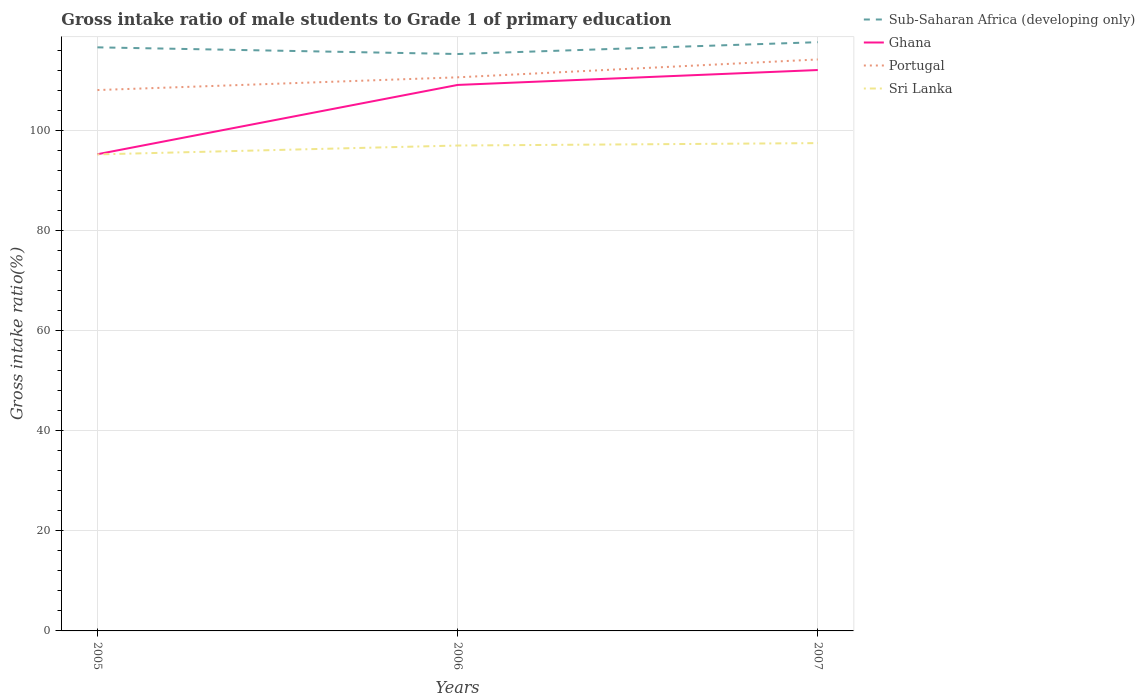How many different coloured lines are there?
Ensure brevity in your answer.  4. Does the line corresponding to Portugal intersect with the line corresponding to Ghana?
Ensure brevity in your answer.  No. Across all years, what is the maximum gross intake ratio in Sri Lanka?
Keep it short and to the point. 95.27. What is the total gross intake ratio in Sub-Saharan Africa (developing only) in the graph?
Offer a very short reply. 1.33. What is the difference between the highest and the second highest gross intake ratio in Sri Lanka?
Your answer should be very brief. 2.26. How many years are there in the graph?
Give a very brief answer. 3. Where does the legend appear in the graph?
Give a very brief answer. Top right. How many legend labels are there?
Provide a short and direct response. 4. How are the legend labels stacked?
Offer a very short reply. Vertical. What is the title of the graph?
Provide a short and direct response. Gross intake ratio of male students to Grade 1 of primary education. Does "Turkmenistan" appear as one of the legend labels in the graph?
Offer a very short reply. No. What is the label or title of the X-axis?
Offer a very short reply. Years. What is the label or title of the Y-axis?
Make the answer very short. Gross intake ratio(%). What is the Gross intake ratio(%) of Sub-Saharan Africa (developing only) in 2005?
Provide a short and direct response. 116.67. What is the Gross intake ratio(%) of Ghana in 2005?
Offer a terse response. 95.3. What is the Gross intake ratio(%) of Portugal in 2005?
Your answer should be compact. 108.13. What is the Gross intake ratio(%) in Sri Lanka in 2005?
Your answer should be compact. 95.27. What is the Gross intake ratio(%) in Sub-Saharan Africa (developing only) in 2006?
Make the answer very short. 115.34. What is the Gross intake ratio(%) in Ghana in 2006?
Ensure brevity in your answer.  109.15. What is the Gross intake ratio(%) of Portugal in 2006?
Keep it short and to the point. 110.68. What is the Gross intake ratio(%) in Sri Lanka in 2006?
Make the answer very short. 97.04. What is the Gross intake ratio(%) in Sub-Saharan Africa (developing only) in 2007?
Your answer should be very brief. 117.7. What is the Gross intake ratio(%) in Ghana in 2007?
Your answer should be compact. 112.13. What is the Gross intake ratio(%) of Portugal in 2007?
Your answer should be very brief. 114.25. What is the Gross intake ratio(%) of Sri Lanka in 2007?
Your answer should be very brief. 97.52. Across all years, what is the maximum Gross intake ratio(%) in Sub-Saharan Africa (developing only)?
Make the answer very short. 117.7. Across all years, what is the maximum Gross intake ratio(%) in Ghana?
Give a very brief answer. 112.13. Across all years, what is the maximum Gross intake ratio(%) of Portugal?
Give a very brief answer. 114.25. Across all years, what is the maximum Gross intake ratio(%) in Sri Lanka?
Your answer should be very brief. 97.52. Across all years, what is the minimum Gross intake ratio(%) in Sub-Saharan Africa (developing only)?
Your answer should be very brief. 115.34. Across all years, what is the minimum Gross intake ratio(%) of Ghana?
Provide a succinct answer. 95.3. Across all years, what is the minimum Gross intake ratio(%) of Portugal?
Keep it short and to the point. 108.13. Across all years, what is the minimum Gross intake ratio(%) of Sri Lanka?
Your response must be concise. 95.27. What is the total Gross intake ratio(%) of Sub-Saharan Africa (developing only) in the graph?
Make the answer very short. 349.71. What is the total Gross intake ratio(%) in Ghana in the graph?
Your answer should be very brief. 316.59. What is the total Gross intake ratio(%) in Portugal in the graph?
Make the answer very short. 333.06. What is the total Gross intake ratio(%) of Sri Lanka in the graph?
Give a very brief answer. 289.83. What is the difference between the Gross intake ratio(%) of Sub-Saharan Africa (developing only) in 2005 and that in 2006?
Offer a terse response. 1.33. What is the difference between the Gross intake ratio(%) in Ghana in 2005 and that in 2006?
Your response must be concise. -13.85. What is the difference between the Gross intake ratio(%) of Portugal in 2005 and that in 2006?
Make the answer very short. -2.55. What is the difference between the Gross intake ratio(%) of Sri Lanka in 2005 and that in 2006?
Keep it short and to the point. -1.78. What is the difference between the Gross intake ratio(%) of Sub-Saharan Africa (developing only) in 2005 and that in 2007?
Make the answer very short. -1.03. What is the difference between the Gross intake ratio(%) of Ghana in 2005 and that in 2007?
Keep it short and to the point. -16.83. What is the difference between the Gross intake ratio(%) of Portugal in 2005 and that in 2007?
Provide a short and direct response. -6.12. What is the difference between the Gross intake ratio(%) in Sri Lanka in 2005 and that in 2007?
Make the answer very short. -2.26. What is the difference between the Gross intake ratio(%) of Sub-Saharan Africa (developing only) in 2006 and that in 2007?
Make the answer very short. -2.36. What is the difference between the Gross intake ratio(%) of Ghana in 2006 and that in 2007?
Offer a terse response. -2.98. What is the difference between the Gross intake ratio(%) of Portugal in 2006 and that in 2007?
Your response must be concise. -3.57. What is the difference between the Gross intake ratio(%) in Sri Lanka in 2006 and that in 2007?
Your answer should be very brief. -0.48. What is the difference between the Gross intake ratio(%) in Sub-Saharan Africa (developing only) in 2005 and the Gross intake ratio(%) in Ghana in 2006?
Ensure brevity in your answer.  7.52. What is the difference between the Gross intake ratio(%) of Sub-Saharan Africa (developing only) in 2005 and the Gross intake ratio(%) of Portugal in 2006?
Your response must be concise. 5.99. What is the difference between the Gross intake ratio(%) in Sub-Saharan Africa (developing only) in 2005 and the Gross intake ratio(%) in Sri Lanka in 2006?
Provide a succinct answer. 19.63. What is the difference between the Gross intake ratio(%) in Ghana in 2005 and the Gross intake ratio(%) in Portugal in 2006?
Your response must be concise. -15.38. What is the difference between the Gross intake ratio(%) of Ghana in 2005 and the Gross intake ratio(%) of Sri Lanka in 2006?
Your answer should be very brief. -1.74. What is the difference between the Gross intake ratio(%) of Portugal in 2005 and the Gross intake ratio(%) of Sri Lanka in 2006?
Provide a short and direct response. 11.09. What is the difference between the Gross intake ratio(%) of Sub-Saharan Africa (developing only) in 2005 and the Gross intake ratio(%) of Ghana in 2007?
Give a very brief answer. 4.54. What is the difference between the Gross intake ratio(%) in Sub-Saharan Africa (developing only) in 2005 and the Gross intake ratio(%) in Portugal in 2007?
Keep it short and to the point. 2.42. What is the difference between the Gross intake ratio(%) in Sub-Saharan Africa (developing only) in 2005 and the Gross intake ratio(%) in Sri Lanka in 2007?
Offer a terse response. 19.15. What is the difference between the Gross intake ratio(%) of Ghana in 2005 and the Gross intake ratio(%) of Portugal in 2007?
Offer a very short reply. -18.95. What is the difference between the Gross intake ratio(%) in Ghana in 2005 and the Gross intake ratio(%) in Sri Lanka in 2007?
Offer a terse response. -2.22. What is the difference between the Gross intake ratio(%) in Portugal in 2005 and the Gross intake ratio(%) in Sri Lanka in 2007?
Provide a short and direct response. 10.61. What is the difference between the Gross intake ratio(%) of Sub-Saharan Africa (developing only) in 2006 and the Gross intake ratio(%) of Ghana in 2007?
Offer a very short reply. 3.2. What is the difference between the Gross intake ratio(%) in Sub-Saharan Africa (developing only) in 2006 and the Gross intake ratio(%) in Portugal in 2007?
Offer a very short reply. 1.09. What is the difference between the Gross intake ratio(%) in Sub-Saharan Africa (developing only) in 2006 and the Gross intake ratio(%) in Sri Lanka in 2007?
Your response must be concise. 17.81. What is the difference between the Gross intake ratio(%) in Ghana in 2006 and the Gross intake ratio(%) in Portugal in 2007?
Give a very brief answer. -5.09. What is the difference between the Gross intake ratio(%) in Ghana in 2006 and the Gross intake ratio(%) in Sri Lanka in 2007?
Your response must be concise. 11.63. What is the difference between the Gross intake ratio(%) in Portugal in 2006 and the Gross intake ratio(%) in Sri Lanka in 2007?
Make the answer very short. 13.15. What is the average Gross intake ratio(%) in Sub-Saharan Africa (developing only) per year?
Provide a succinct answer. 116.57. What is the average Gross intake ratio(%) in Ghana per year?
Provide a short and direct response. 105.53. What is the average Gross intake ratio(%) in Portugal per year?
Your answer should be compact. 111.02. What is the average Gross intake ratio(%) of Sri Lanka per year?
Offer a terse response. 96.61. In the year 2005, what is the difference between the Gross intake ratio(%) of Sub-Saharan Africa (developing only) and Gross intake ratio(%) of Ghana?
Provide a short and direct response. 21.37. In the year 2005, what is the difference between the Gross intake ratio(%) in Sub-Saharan Africa (developing only) and Gross intake ratio(%) in Portugal?
Make the answer very short. 8.54. In the year 2005, what is the difference between the Gross intake ratio(%) in Sub-Saharan Africa (developing only) and Gross intake ratio(%) in Sri Lanka?
Offer a terse response. 21.4. In the year 2005, what is the difference between the Gross intake ratio(%) in Ghana and Gross intake ratio(%) in Portugal?
Your answer should be very brief. -12.83. In the year 2005, what is the difference between the Gross intake ratio(%) of Ghana and Gross intake ratio(%) of Sri Lanka?
Offer a very short reply. 0.03. In the year 2005, what is the difference between the Gross intake ratio(%) of Portugal and Gross intake ratio(%) of Sri Lanka?
Make the answer very short. 12.86. In the year 2006, what is the difference between the Gross intake ratio(%) of Sub-Saharan Africa (developing only) and Gross intake ratio(%) of Ghana?
Your response must be concise. 6.18. In the year 2006, what is the difference between the Gross intake ratio(%) in Sub-Saharan Africa (developing only) and Gross intake ratio(%) in Portugal?
Make the answer very short. 4.66. In the year 2006, what is the difference between the Gross intake ratio(%) in Sub-Saharan Africa (developing only) and Gross intake ratio(%) in Sri Lanka?
Offer a very short reply. 18.3. In the year 2006, what is the difference between the Gross intake ratio(%) in Ghana and Gross intake ratio(%) in Portugal?
Offer a terse response. -1.52. In the year 2006, what is the difference between the Gross intake ratio(%) of Ghana and Gross intake ratio(%) of Sri Lanka?
Offer a terse response. 12.11. In the year 2006, what is the difference between the Gross intake ratio(%) of Portugal and Gross intake ratio(%) of Sri Lanka?
Keep it short and to the point. 13.64. In the year 2007, what is the difference between the Gross intake ratio(%) in Sub-Saharan Africa (developing only) and Gross intake ratio(%) in Ghana?
Your answer should be compact. 5.57. In the year 2007, what is the difference between the Gross intake ratio(%) in Sub-Saharan Africa (developing only) and Gross intake ratio(%) in Portugal?
Offer a very short reply. 3.45. In the year 2007, what is the difference between the Gross intake ratio(%) of Sub-Saharan Africa (developing only) and Gross intake ratio(%) of Sri Lanka?
Provide a succinct answer. 20.18. In the year 2007, what is the difference between the Gross intake ratio(%) in Ghana and Gross intake ratio(%) in Portugal?
Offer a very short reply. -2.12. In the year 2007, what is the difference between the Gross intake ratio(%) in Ghana and Gross intake ratio(%) in Sri Lanka?
Your answer should be compact. 14.61. In the year 2007, what is the difference between the Gross intake ratio(%) of Portugal and Gross intake ratio(%) of Sri Lanka?
Offer a terse response. 16.72. What is the ratio of the Gross intake ratio(%) of Sub-Saharan Africa (developing only) in 2005 to that in 2006?
Ensure brevity in your answer.  1.01. What is the ratio of the Gross intake ratio(%) in Ghana in 2005 to that in 2006?
Offer a terse response. 0.87. What is the ratio of the Gross intake ratio(%) of Portugal in 2005 to that in 2006?
Keep it short and to the point. 0.98. What is the ratio of the Gross intake ratio(%) of Sri Lanka in 2005 to that in 2006?
Provide a succinct answer. 0.98. What is the ratio of the Gross intake ratio(%) of Sub-Saharan Africa (developing only) in 2005 to that in 2007?
Offer a terse response. 0.99. What is the ratio of the Gross intake ratio(%) of Ghana in 2005 to that in 2007?
Keep it short and to the point. 0.85. What is the ratio of the Gross intake ratio(%) in Portugal in 2005 to that in 2007?
Provide a short and direct response. 0.95. What is the ratio of the Gross intake ratio(%) in Sri Lanka in 2005 to that in 2007?
Keep it short and to the point. 0.98. What is the ratio of the Gross intake ratio(%) of Sub-Saharan Africa (developing only) in 2006 to that in 2007?
Keep it short and to the point. 0.98. What is the ratio of the Gross intake ratio(%) of Ghana in 2006 to that in 2007?
Offer a very short reply. 0.97. What is the ratio of the Gross intake ratio(%) in Portugal in 2006 to that in 2007?
Ensure brevity in your answer.  0.97. What is the ratio of the Gross intake ratio(%) of Sri Lanka in 2006 to that in 2007?
Provide a short and direct response. 1. What is the difference between the highest and the second highest Gross intake ratio(%) in Sub-Saharan Africa (developing only)?
Your answer should be compact. 1.03. What is the difference between the highest and the second highest Gross intake ratio(%) of Ghana?
Provide a succinct answer. 2.98. What is the difference between the highest and the second highest Gross intake ratio(%) of Portugal?
Offer a terse response. 3.57. What is the difference between the highest and the second highest Gross intake ratio(%) in Sri Lanka?
Offer a very short reply. 0.48. What is the difference between the highest and the lowest Gross intake ratio(%) of Sub-Saharan Africa (developing only)?
Provide a short and direct response. 2.36. What is the difference between the highest and the lowest Gross intake ratio(%) of Ghana?
Your answer should be very brief. 16.83. What is the difference between the highest and the lowest Gross intake ratio(%) of Portugal?
Ensure brevity in your answer.  6.12. What is the difference between the highest and the lowest Gross intake ratio(%) in Sri Lanka?
Make the answer very short. 2.26. 